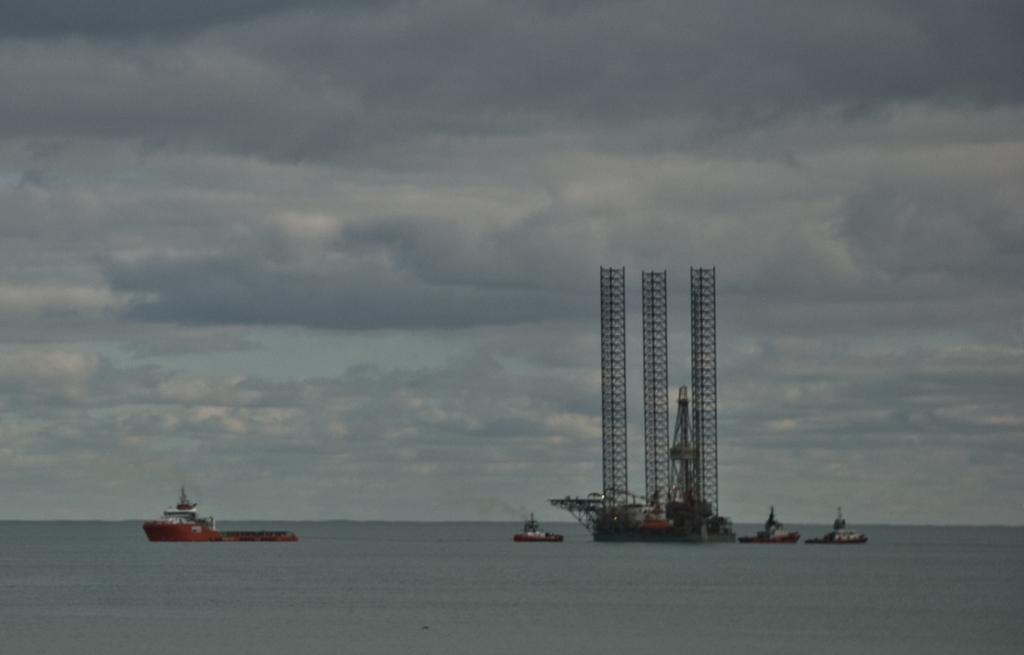What type of water body is visible in the image? The image contains a water body, but the specific type is not mentioned. Where is the ship located in the image? There is a ship on the left side of the image. What can be seen in the center of the image? There are ships and an oil refinery station in the center of the image. What is the condition of the sky in the image? The sky is cloudy in the image. Can you tell me how many quills are being used to write on the ship in the image? There is no mention of quills or writing in the image; it features a water body, ships, and an oil refinery station. Has there been an earthquake in the image? There is no indication of an earthquake in the image. 